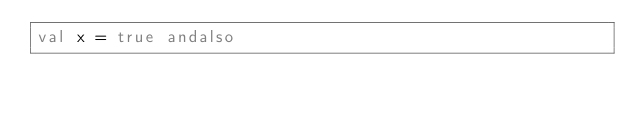<code> <loc_0><loc_0><loc_500><loc_500><_SML_>val x = true andalso
</code> 